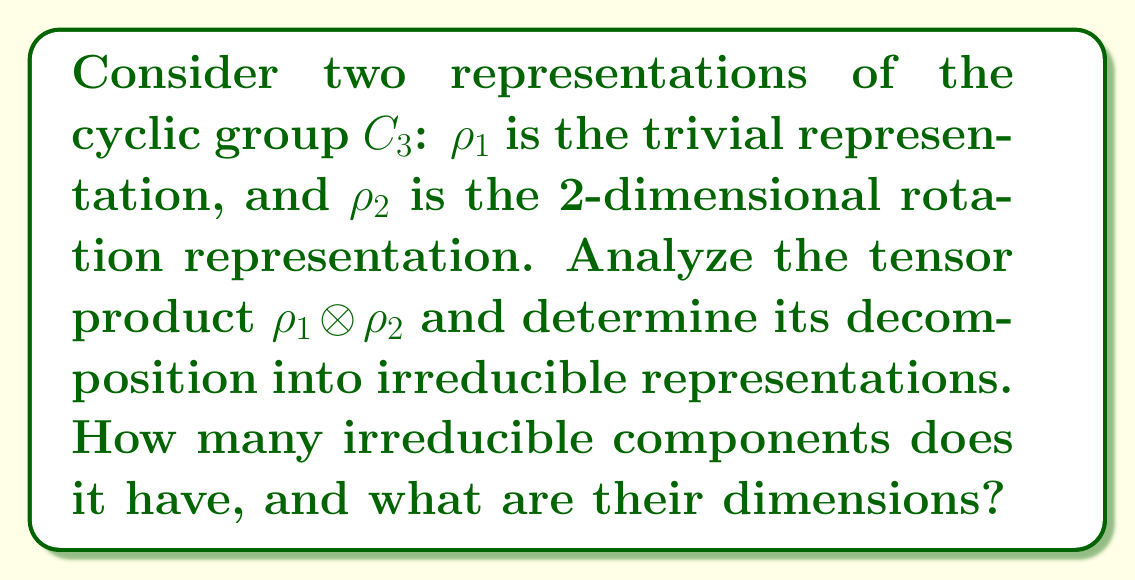What is the answer to this math problem? Let's approach this step-by-step:

1) First, recall that for $C_3$, there are three irreducible representations:
   - The trivial representation (1-dimensional)
   - Two 1-dimensional non-trivial representations

2) $\rho_1$ is the trivial representation, so it maps every element of $C_3$ to the identity matrix [1].

3) $\rho_2$ is the 2-dimensional rotation representation. It can be represented as:
   $$\rho_2(1) = \begin{pmatrix} 1 & 0 \\ 0 & 1 \end{pmatrix}, 
     \rho_2(\omega) = \begin{pmatrix} \cos(2\pi/3) & -\sin(2\pi/3) \\ \sin(2\pi/3) & \cos(2\pi/3) \end{pmatrix}, 
     \rho_2(\omega^2) = \begin{pmatrix} \cos(4\pi/3) & -\sin(4\pi/3) \\ \sin(4\pi/3) & \cos(4\pi/3) \end{pmatrix}$$
   where $\omega$ is a generator of $C_3$.

4) The tensor product $\rho_1 \otimes \rho_2$ will be 2-dimensional because:
   $\dim(\rho_1 \otimes \rho_2) = \dim(\rho_1) \cdot \dim(\rho_2) = 1 \cdot 2 = 2$

5) For any $g \in C_3$, $(\rho_1 \otimes \rho_2)(g) = \rho_1(g) \otimes \rho_2(g) = 1 \cdot \rho_2(g) = \rho_2(g)$

6) This means that $\rho_1 \otimes \rho_2$ is isomorphic to $\rho_2$.

7) Since $\rho_2$ is already an irreducible representation of $C_3$, $\rho_1 \otimes \rho_2$ is also irreducible.

Therefore, $\rho_1 \otimes \rho_2$ decomposes into a single irreducible component, which is 2-dimensional.
Answer: 1 irreducible component of dimension 2 